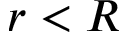Convert formula to latex. <formula><loc_0><loc_0><loc_500><loc_500>r < R</formula> 